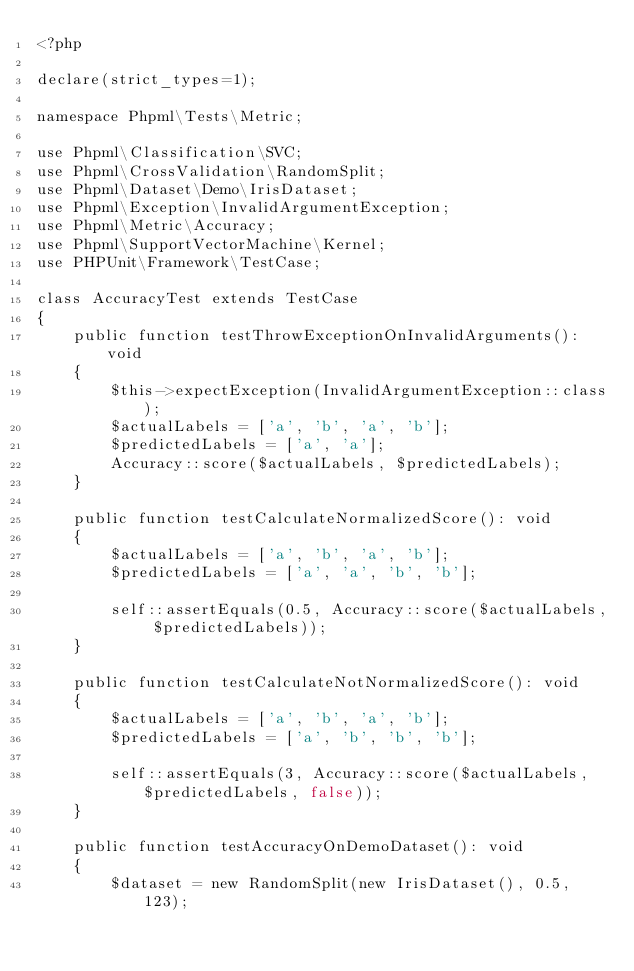<code> <loc_0><loc_0><loc_500><loc_500><_PHP_><?php

declare(strict_types=1);

namespace Phpml\Tests\Metric;

use Phpml\Classification\SVC;
use Phpml\CrossValidation\RandomSplit;
use Phpml\Dataset\Demo\IrisDataset;
use Phpml\Exception\InvalidArgumentException;
use Phpml\Metric\Accuracy;
use Phpml\SupportVectorMachine\Kernel;
use PHPUnit\Framework\TestCase;

class AccuracyTest extends TestCase
{
    public function testThrowExceptionOnInvalidArguments(): void
    {
        $this->expectException(InvalidArgumentException::class);
        $actualLabels = ['a', 'b', 'a', 'b'];
        $predictedLabels = ['a', 'a'];
        Accuracy::score($actualLabels, $predictedLabels);
    }

    public function testCalculateNormalizedScore(): void
    {
        $actualLabels = ['a', 'b', 'a', 'b'];
        $predictedLabels = ['a', 'a', 'b', 'b'];

        self::assertEquals(0.5, Accuracy::score($actualLabels, $predictedLabels));
    }

    public function testCalculateNotNormalizedScore(): void
    {
        $actualLabels = ['a', 'b', 'a', 'b'];
        $predictedLabels = ['a', 'b', 'b', 'b'];

        self::assertEquals(3, Accuracy::score($actualLabels, $predictedLabels, false));
    }

    public function testAccuracyOnDemoDataset(): void
    {
        $dataset = new RandomSplit(new IrisDataset(), 0.5, 123);
</code> 